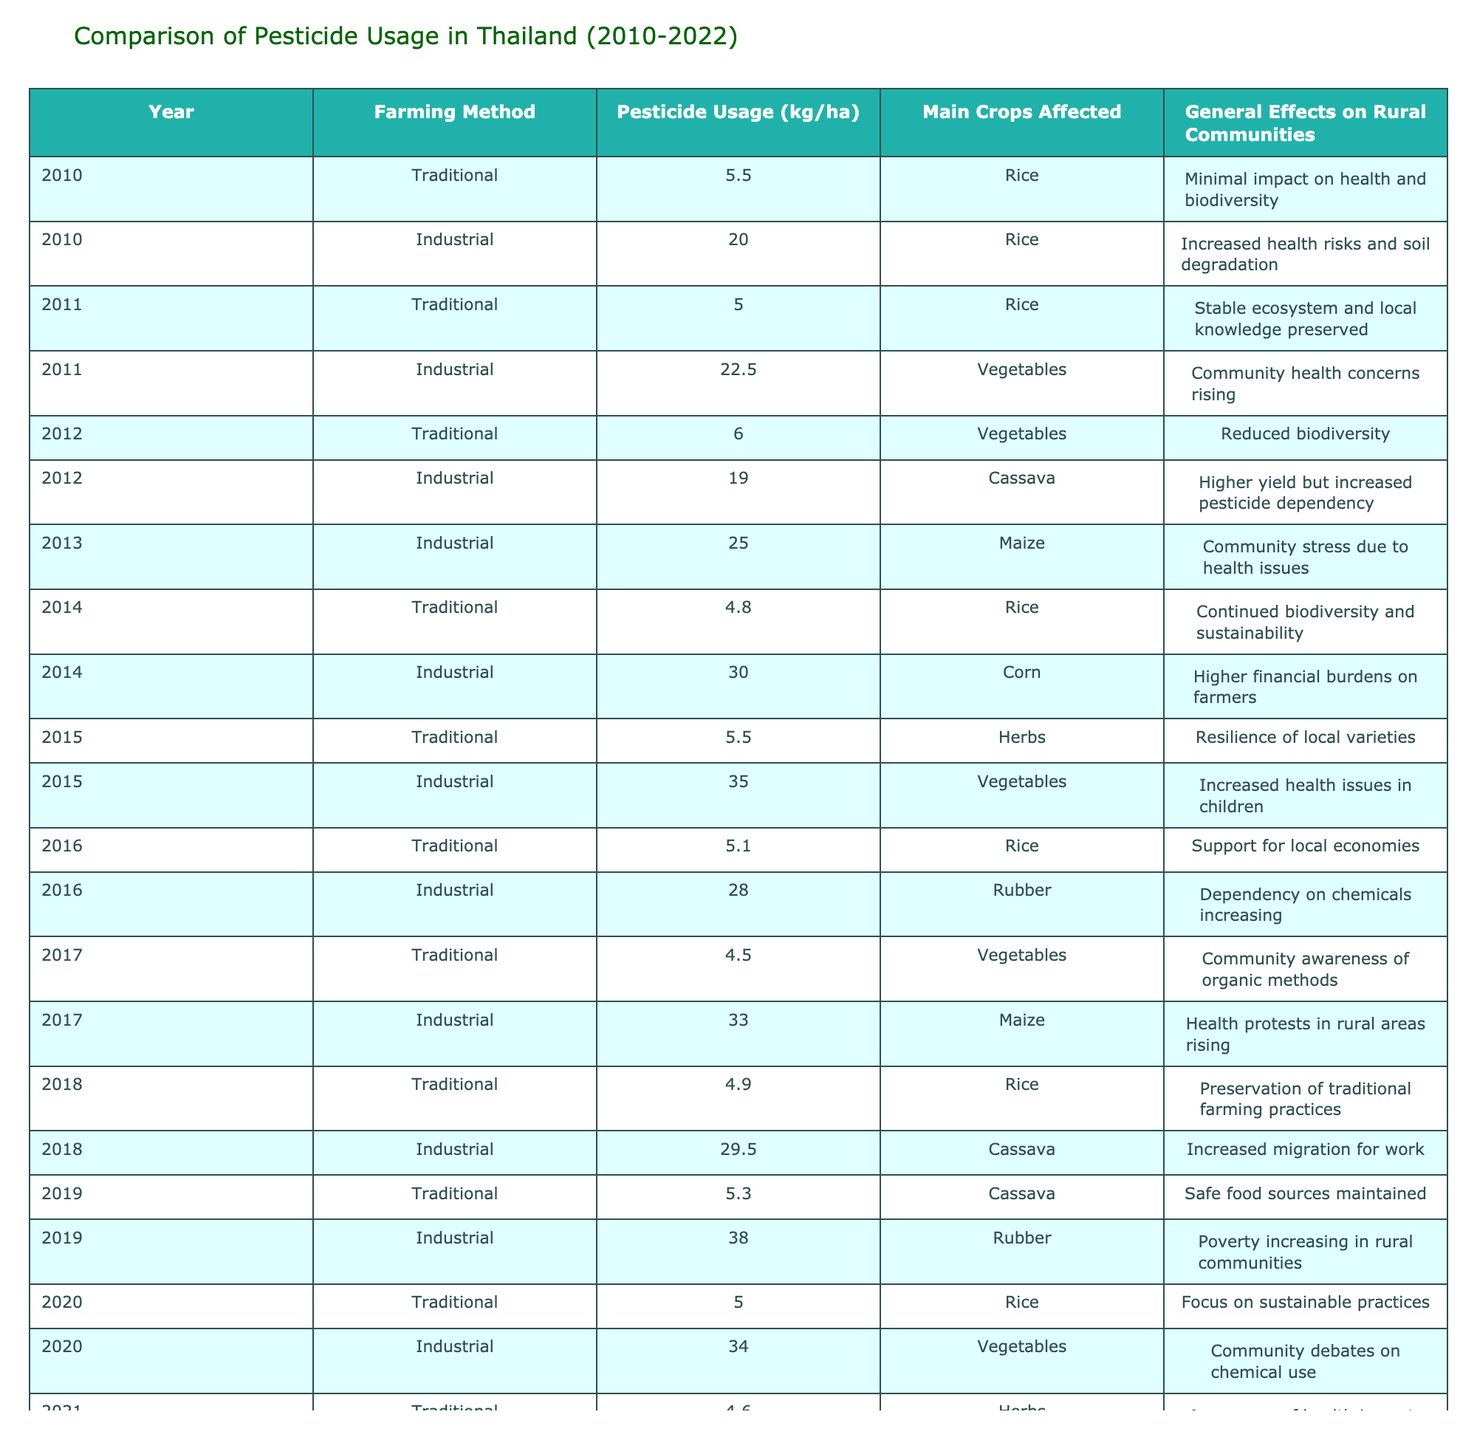What was the pesticide usage in industrial farming in 2015? In the row for the year 2015 and the farming method industrial, the pesticide usage is listed as 35.0 kg/ha.
Answer: 35.0 kg/ha How much pesticide was used in traditional farming in 2020 compared to industrial farming in the same year? For the year 2020, traditional farming had a pesticide usage of 5.0 kg/ha, while industrial farming used 34.0 kg/ha. The difference is 34.0 – 5.0 = 29.0 kg/ha.
Answer: 29.0 kg/ha Did the pesticide usage in traditional farming increase from 2010 to 2022? In reviewing the values from the respective years, traditional farming had 5.5 kg/ha in 2010 and 5.2 kg/ha in 2022, indicating a decrease. Hence, the statement is false.
Answer: No What was the trend of pesticide usage in industrial farming from 2010 to 2022? The pesticide usage in industrial farming started at 20.0 kg/ha in 2010, then increased to 38.0 kg/ha in 2019. By 2022, it decreased to 31.0 kg/ha. This indicates an overall increase followed by a decrease, but a peak in 2019.
Answer: Increase and then decrease What is the average pesticide usage for traditional farming from 2010 to 2022? Listing the values from the table: 5.5, 5.0, 6.0, 4.8, 5.5, 5.1, 4.5, 4.9, 5.3, 5.0, 4.6, 5.2 (12 data points). The sum is 61.0, therefore the average is 61.0 / 12 = 5.08 kg/ha.
Answer: 5.08 kg/ha How many years had industrial farming pesticide usage over 30 kg/ha? Reviewing the data for industrial farming, it was above 30 kg/ha in the years 2014 (30.0), 2015 (35.0), 2016 (28.0), 2017 (33.0), 2018 (29.5), 2019 (38.0), 2020 (34.0), and 2021 (36.5). The count of years above 30 kg/ha is 5.
Answer: 5 years Was there an increase in health concerns associated with industrial farming methods over the years? In the effects noted over the years, health concerns start with "Increased health risks" in 2010 and escalate in 2015 with "Increased health issues in children" and 2019 with "Poverty increasing in rural communities". This suggests a trend of rising health concerns associated with industrial methods.
Answer: Yes What is the difference in pesticide usage between traditional and industrial farming in the year 2018? In 2018, traditional farming usage was 4.9 kg/ha and industrial was 29.5 kg/ha. The difference is 29.5 – 4.9 = 24.6 kg/ha.
Answer: 24.6 kg/ha 